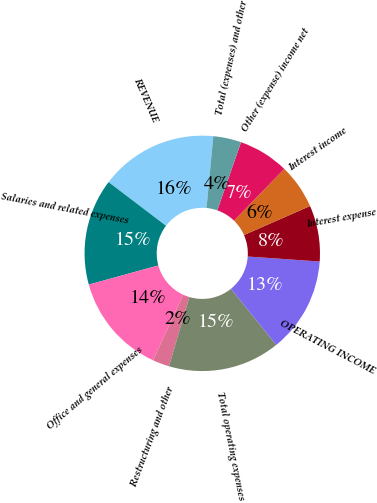<chart> <loc_0><loc_0><loc_500><loc_500><pie_chart><fcel>REVENUE<fcel>Salaries and related expenses<fcel>Office and general expenses<fcel>Restructuring and other<fcel>Total operating expenses<fcel>OPERATING INCOME<fcel>Interest expense<fcel>Interest income<fcel>Other (expense) income net<fcel>Total (expenses) and other<nl><fcel>16.15%<fcel>14.62%<fcel>13.85%<fcel>2.31%<fcel>15.38%<fcel>13.08%<fcel>7.69%<fcel>6.15%<fcel>6.92%<fcel>3.85%<nl></chart> 